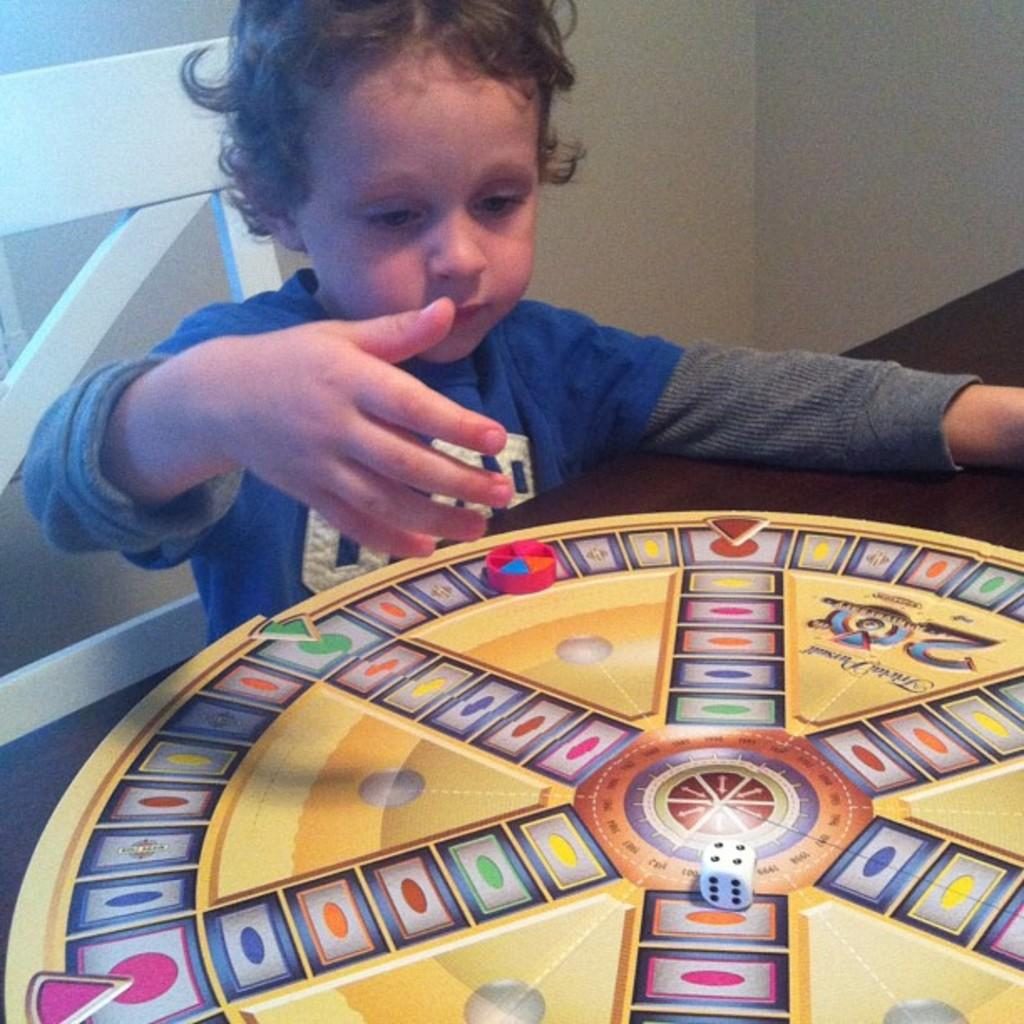What is on the wooden table in the image? There is a game on a wooden table in the image. What is the child in the image doing? The child is sitting on a chair in the image. What color is the child's T-shirt? The child is wearing a blue T-shirt. What can be seen in the background of the image? There is a wall visible in the background of the image. How many frogs are sitting on the chair with the child in the image? There are no frogs present in the image; only the child and the game on the table are visible. What type of pen is the beggar using to write in the image? There is no beggar or pen present in the image. 